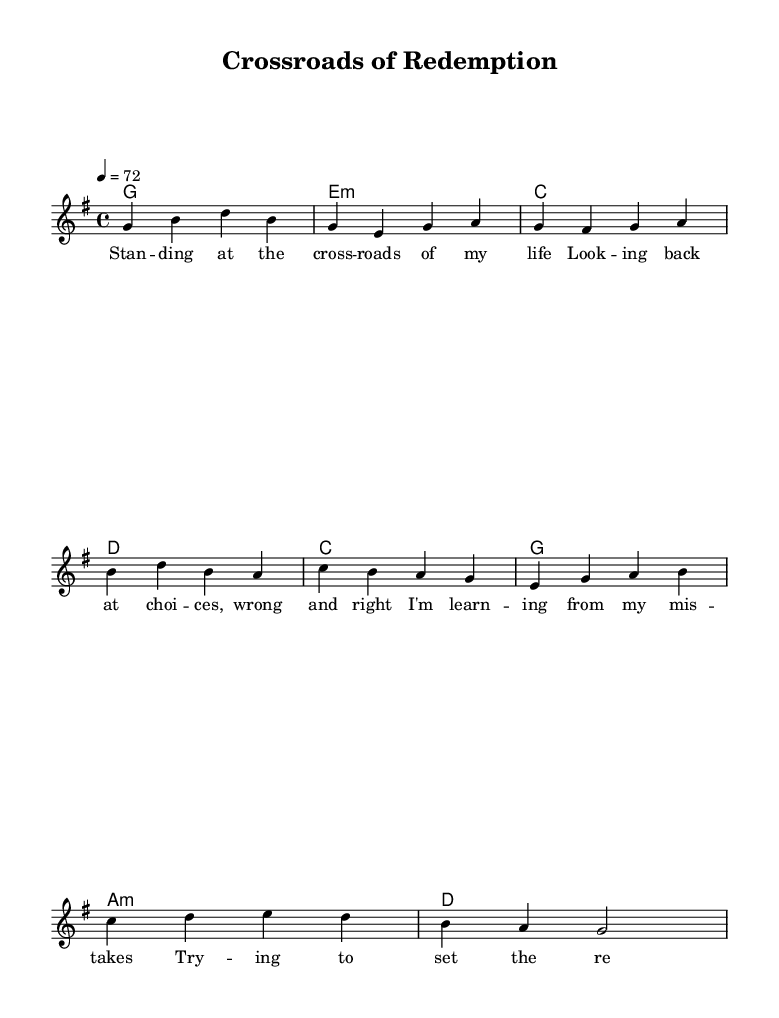What is the key signature of this music? The key signature is G major, which has one sharp (F#). This is identified by the first staff system's key indication before the time signature.
Answer: G major What is the time signature of the piece? The time signature shown in the sheet music is 4/4, which means there are four beats per measure. This is indicated in the same line as the key signature.
Answer: 4/4 What is the tempo marking for this music? The tempo marking is indicated as "4 = 72," meaning a quarter note is played at 72 beats per minute. This is noted in the tempo directive in the sheet music.
Answer: 72 How many measures are there in the verse? Counting the measures in the verse section, we see there are four measures total before transitioning to the chorus. Each group of four beats constitutes a measure.
Answer: 4 What is the overall theme reflected in the lyrics? The lyrics express introspection and personal growth, focusing on choices and the impact of mistakes in life. This can be inferred by reading the lines and understanding the content.
Answer: Introspection Which chords are used in the chorus? The chords used in the chorus include C, G, A minor, and D, as noted in the chord names below the staff corresponding to the melody.
Answer: C, G, A minor, D What type of song structure does this piece follow? The song follows a traditional verse-chorus structure, where the verses set the theme and the chorus reflects on that theme in a broader sense. This can be analyzed by observing the arrangement of the lyrics and melody.
Answer: Verse-Chorus 